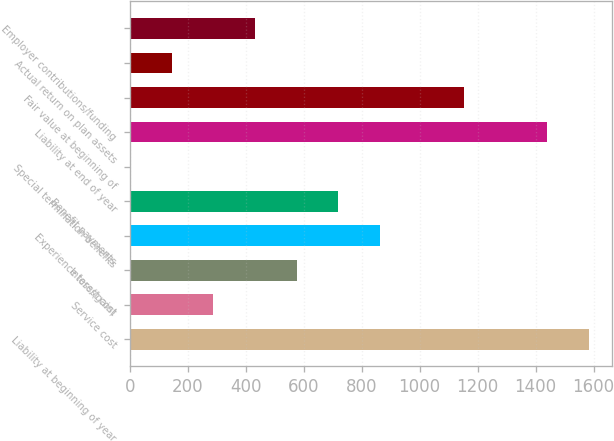<chart> <loc_0><loc_0><loc_500><loc_500><bar_chart><fcel>Liability at beginning of year<fcel>Service cost<fcel>Interest cost<fcel>Experience loss/(gain)<fcel>Benefit payments<fcel>Special termination benefits<fcel>Liability at end of year<fcel>Fair value at beginning of<fcel>Actual return on plan assets<fcel>Employer contributions/funding<nl><fcel>1582.8<fcel>288.6<fcel>576.2<fcel>863.8<fcel>720<fcel>1<fcel>1439<fcel>1151.4<fcel>144.8<fcel>432.4<nl></chart> 